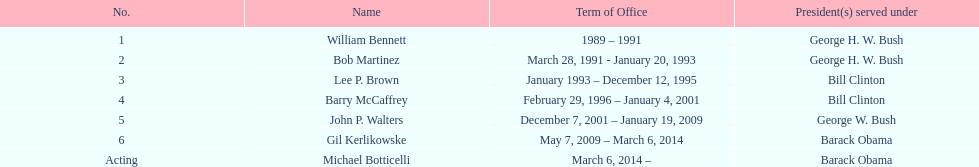Who served during barack obama's presidency? Gil Kerlikowske. 